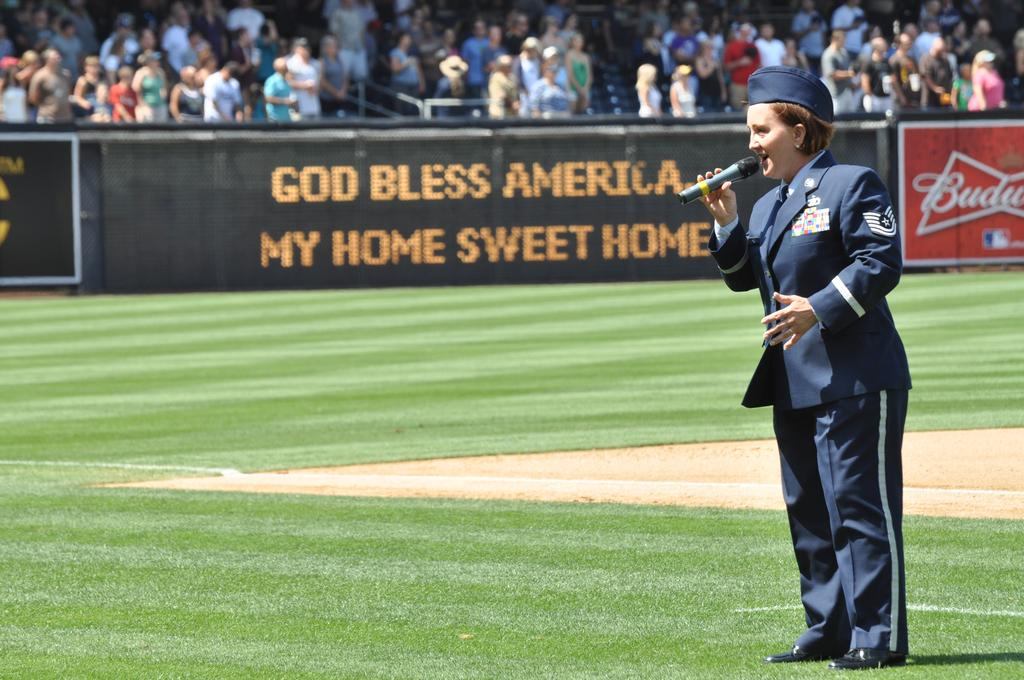<image>
Write a terse but informative summary of the picture. A woman is singing a song in front of a sign reading, God Bless America. 